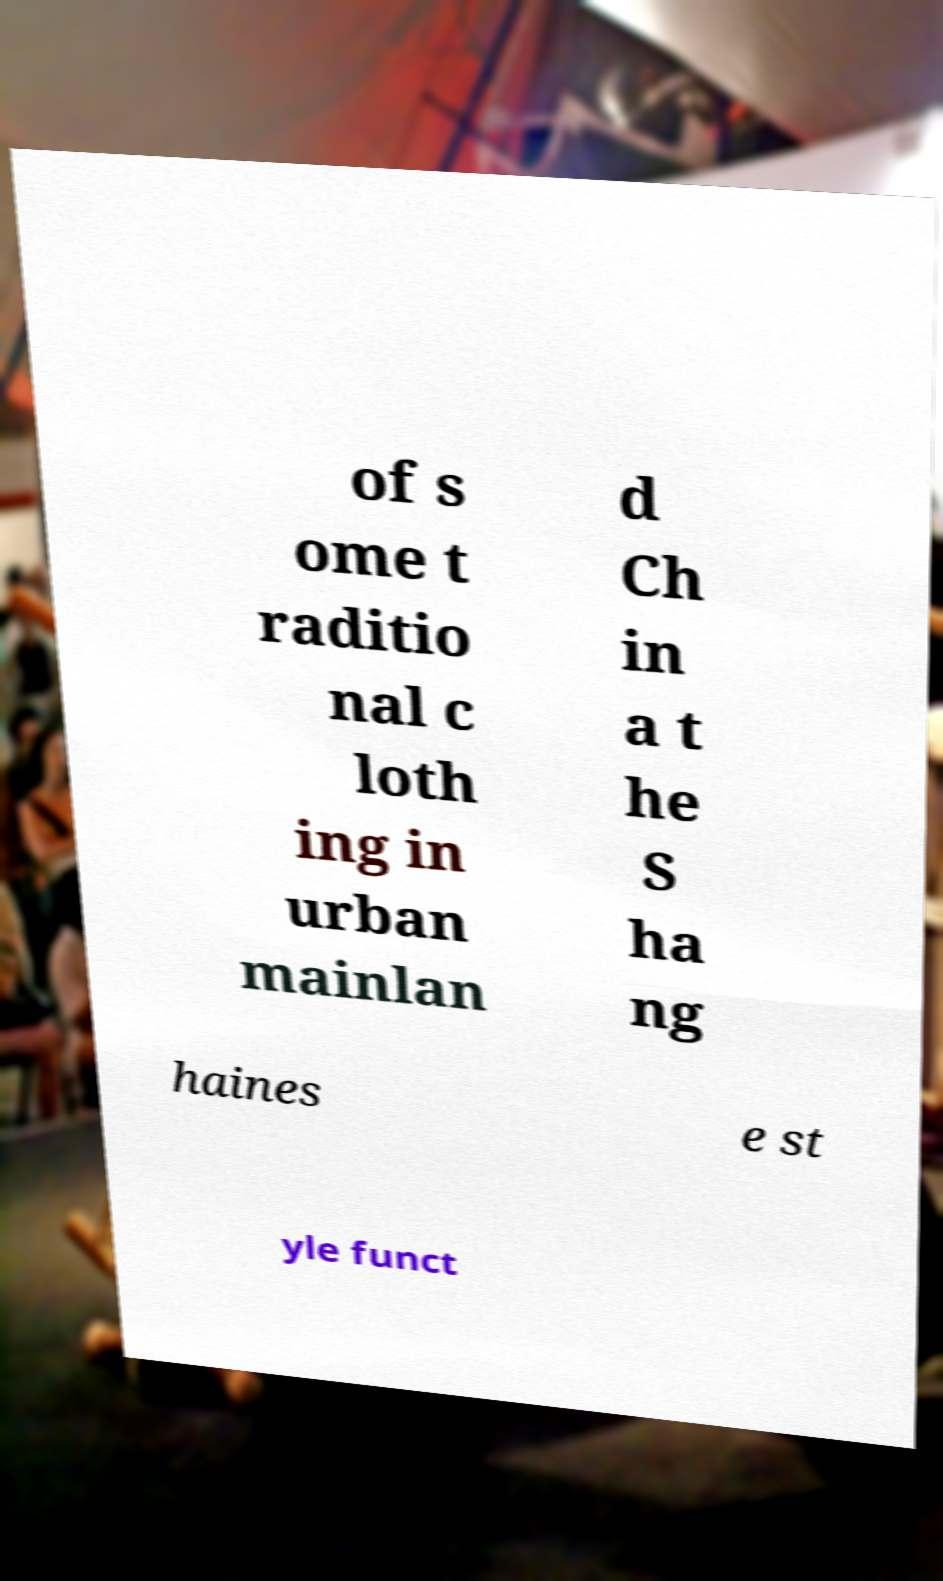I need the written content from this picture converted into text. Can you do that? of s ome t raditio nal c loth ing in urban mainlan d Ch in a t he S ha ng haines e st yle funct 